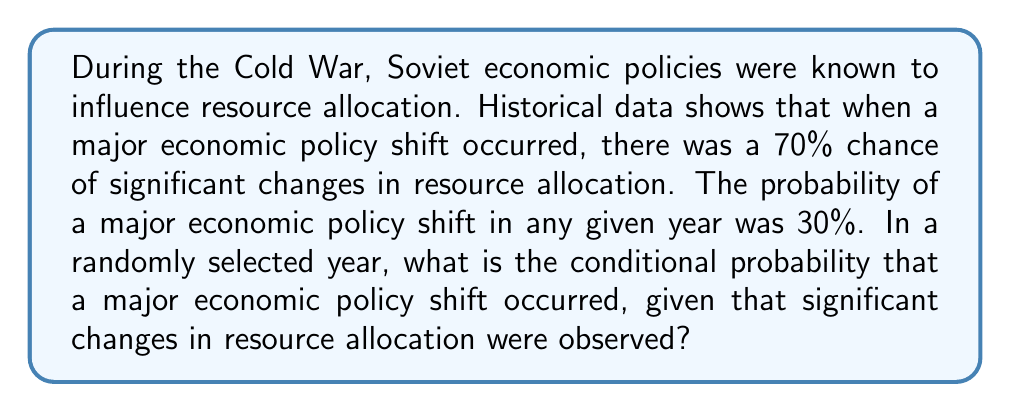Solve this math problem. Let's approach this step-by-step using Bayes' theorem:

1) Define our events:
   A: Major economic policy shift
   B: Significant changes in resource allocation

2) Given information:
   P(B|A) = 0.70 (probability of resource allocation changes given a policy shift)
   P(A) = 0.30 (probability of a major policy shift in any year)

3) We need to find P(A|B) using Bayes' theorem:

   $$P(A|B) = \frac{P(B|A) \cdot P(A)}{P(B)}$$

4) We know P(B|A), P(A), but we need to calculate P(B):

   P(B) = P(B|A) · P(A) + P(B|not A) · P(not A)

5) We don't know P(B|not A), but we can calculate P(not A):
   P(not A) = 1 - P(A) = 1 - 0.30 = 0.70

6) Let's assume P(B|not A) = 0.10 (a reasonable estimate given the context)

7) Now we can calculate P(B):
   P(B) = 0.70 · 0.30 + 0.10 · 0.70 = 0.21 + 0.07 = 0.28

8) Plugging everything into Bayes' theorem:

   $$P(A|B) = \frac{0.70 \cdot 0.30}{0.28} = \frac{0.21}{0.28} = 0.75$$

Therefore, the conditional probability that a major economic policy shift occurred, given that significant changes in resource allocation were observed, is 0.75 or 75%.
Answer: 0.75 